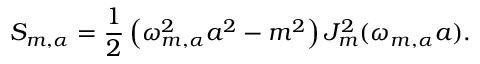Convert formula to latex. <formula><loc_0><loc_0><loc_500><loc_500>S _ { m , \alpha } = \frac { 1 } { 2 } \left ( \omega _ { m , \alpha } ^ { 2 } a ^ { 2 } - m ^ { 2 } \right ) J _ { m } ^ { 2 } ( \omega _ { m , \alpha } a ) .</formula> 